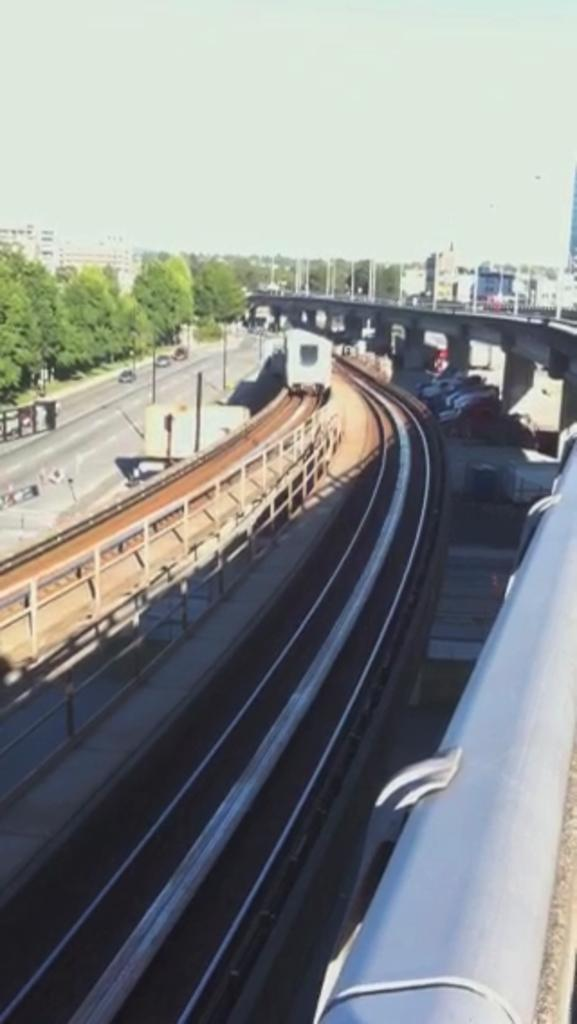What types of transportation can be seen on the roads in the image? There are vehicles on the roads in the image. What is the barrier that separates the roads from the other areas in the image? There is a fence in the image. What type of vegetation is present in the image? There are trees in the image. What structures provide illumination in the image? There are street lights in the image. What mode of transportation can be seen on a railway track in the image? There is a train on a railway track in the image. What can be seen in the background of the image? There are buildings and the sky visible in the background of the image. Can you tell me how many arches are present in the image? There are no arches present in the image. What type of farm animals can be seen grazing in the image? There are no farm animals present in the image. 